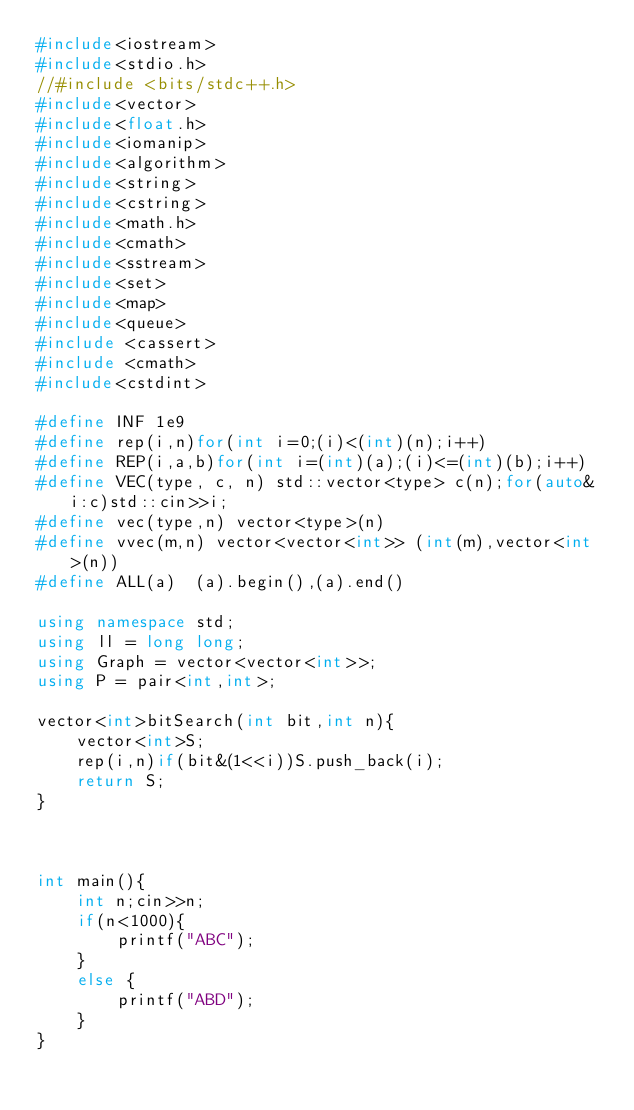Convert code to text. <code><loc_0><loc_0><loc_500><loc_500><_C++_>#include<iostream>
#include<stdio.h>
//#include <bits/stdc++.h>
#include<vector>
#include<float.h>
#include<iomanip>
#include<algorithm>
#include<string>
#include<cstring>
#include<math.h>
#include<cmath>
#include<sstream>
#include<set>
#include<map>
#include<queue>
#include <cassert>
#include <cmath>
#include<cstdint>

#define INF 1e9
#define rep(i,n)for(int i=0;(i)<(int)(n);i++)
#define REP(i,a,b)for(int i=(int)(a);(i)<=(int)(b);i++)
#define VEC(type, c, n) std::vector<type> c(n);for(auto& i:c)std::cin>>i;
#define vec(type,n) vector<type>(n)
#define vvec(m,n) vector<vector<int>> (int(m),vector<int>(n))
#define ALL(a)  (a).begin(),(a).end()

using namespace std;
using ll = long long;
using Graph = vector<vector<int>>;
using P = pair<int,int>;

vector<int>bitSearch(int bit,int n){
    vector<int>S;
    rep(i,n)if(bit&(1<<i))S.push_back(i);
    return S;
}



int main(){
    int n;cin>>n;
    if(n<1000){
        printf("ABC");
    }
    else {
        printf("ABD");
    }
}

</code> 